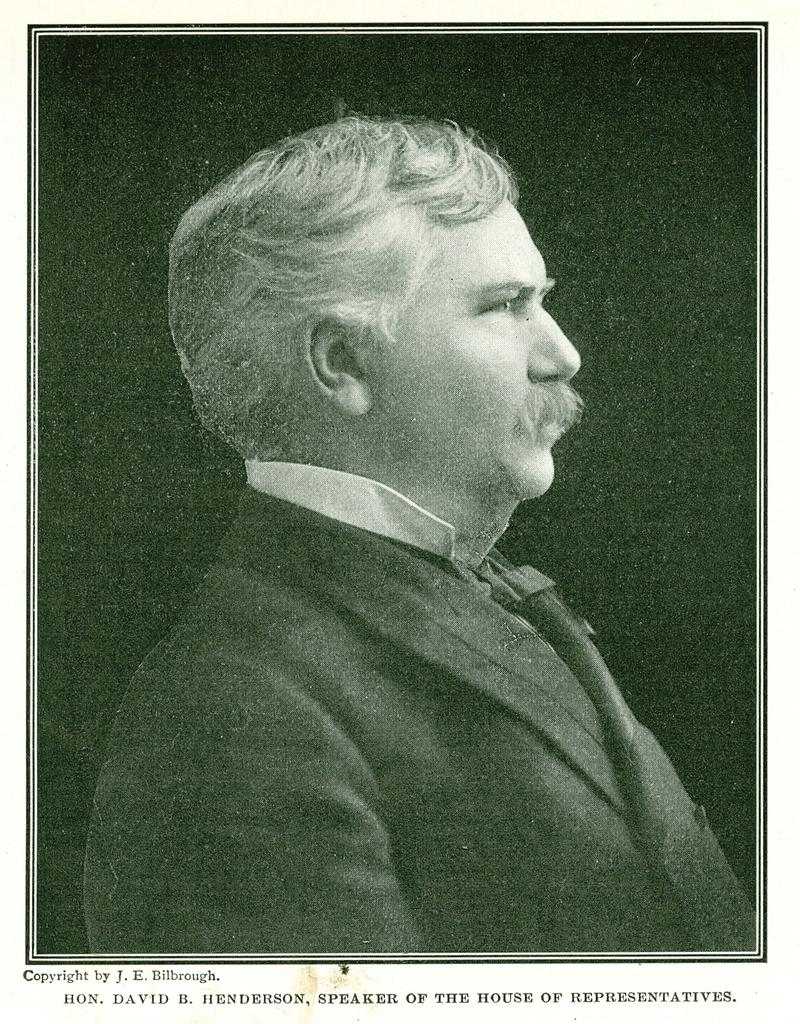What is the person wearing in the image? The person is wearing a blazer in the image. What is the color scheme of the image? The image is black and white. What can be seen written in the image? There is text written in the image. What type of channel can be seen in the image? There is no channel present in the image; it is a person wearing a blazer in a black and white setting with text. What is the person using to water the plants in the image? There are no plants or hoses present in the image. --- Transcript: In this picture we can see a cat sitting on a chair. The chair is red in color. Facts: 1. There is a cat in the picture. 2. The cat is sitting on a chair. 3. The chair is red in color. Absurd Topics: horn, dance, costume Conversation: What animal is in the picture? There is a cat in the picture. What is the cat doing in the image? The cat is sitting on a chair in the image. What color is the chair the cat is sitting on? The chair is red in color. Reasoning: Let's think step by step in order to produce the conversation. We start by identifying the main subject in the image, which is the cat. Then, we describe the cat's action, which is sitting on a chair. Finally, we mention the color of the chair, which is red. Absurd Question/Answer: What type of horn can be seen on the cat's head in the image? There is no horn present on the cat's head in the image. What dance is the cat performing in the image? There is no dance being performed by the cat in the image; it is simply sitting on a chair. --- Transcript: In this image we can see a person holding a camera. The person is wearing a hat. There is a tree in the background. Facts: 1. There is a person in the image. 2. The person is holding a camera. 3. The person is wearing a hat. 4. There is a tree in the background of the image. Absurd Topics: costume, parade, balloon Conversation: What is the person doing in the image? The person is holding a camera in the image. What accessory is the person wearing in the image? The person is wearing a hat in the image. What can be seen in the background of the image? A: There is a tree in the background of the image. Reasoning: Let's think step by step in order to produce the conversation. We start by identifying the main subject in the image, which is the person holding a camera. Then, we mention the accessory the person is wearing, which is a hat. Finally, we describe the background of the image 